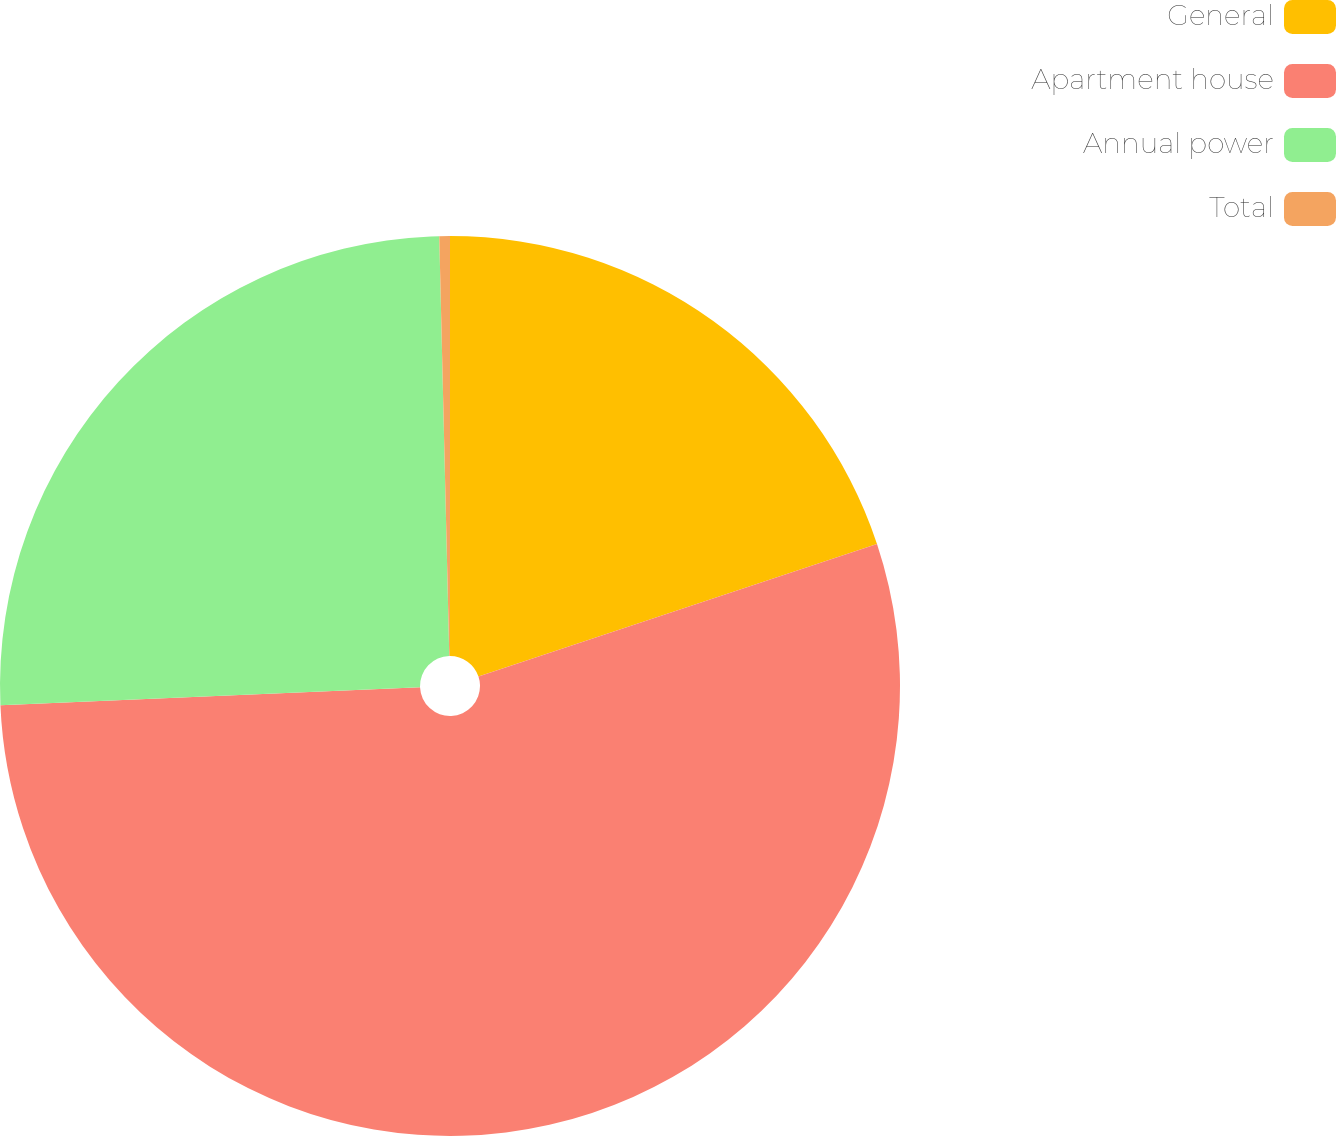Convert chart to OTSL. <chart><loc_0><loc_0><loc_500><loc_500><pie_chart><fcel>General<fcel>Apartment house<fcel>Annual power<fcel>Total<nl><fcel>19.89%<fcel>54.43%<fcel>25.3%<fcel>0.38%<nl></chart> 